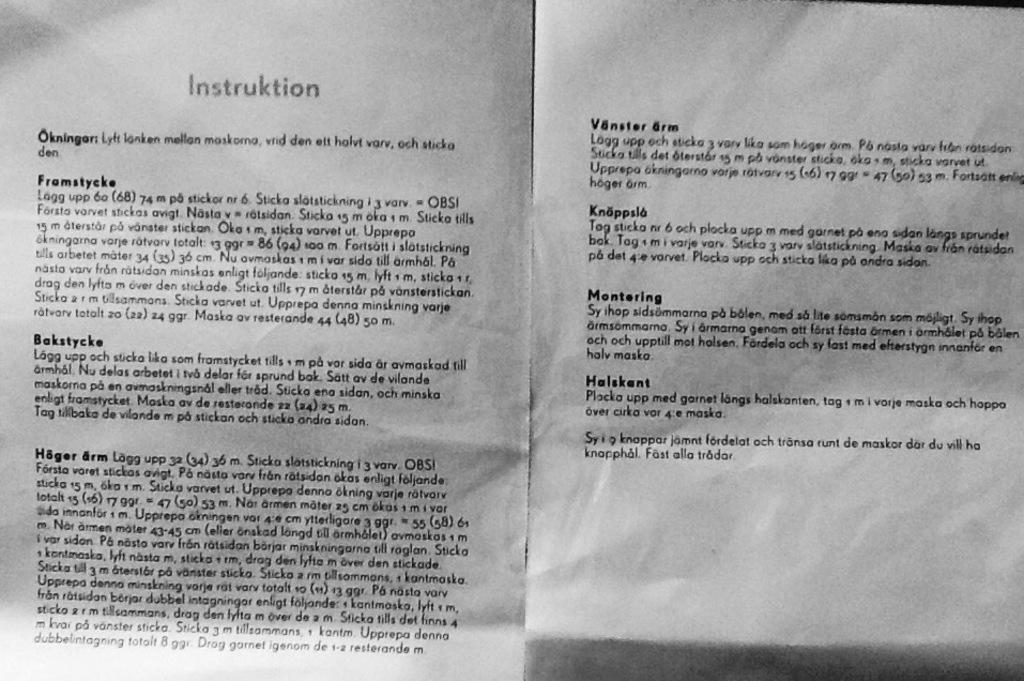<image>
Describe the image concisely. The first section in the instruction manual is Okningor. 